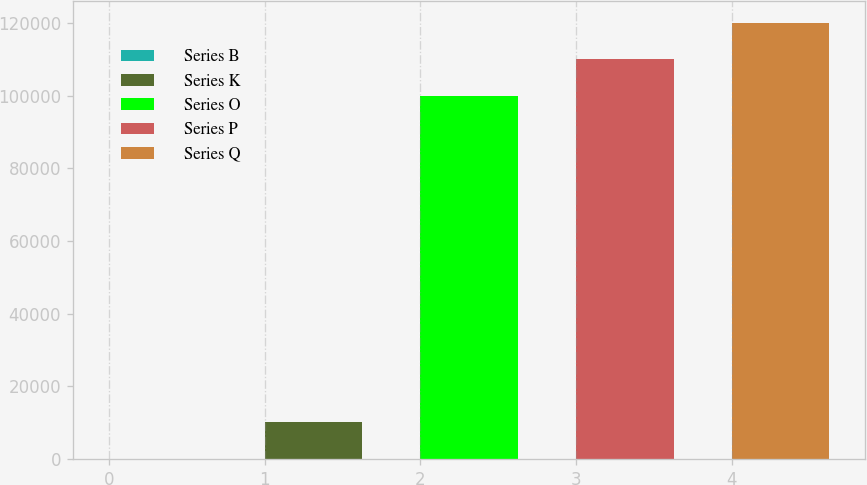Convert chart to OTSL. <chart><loc_0><loc_0><loc_500><loc_500><bar_chart><fcel>Series B<fcel>Series K<fcel>Series O<fcel>Series P<fcel>Series Q<nl><fcel>40<fcel>10036<fcel>100000<fcel>109996<fcel>119992<nl></chart> 